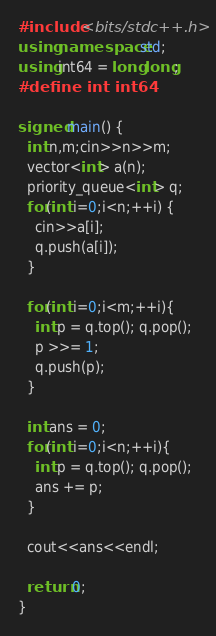Convert code to text. <code><loc_0><loc_0><loc_500><loc_500><_C++_>#include <bits/stdc++.h>
using namespace std;
using int64 = long long;
#define int int64

signed main() {
  int n,m;cin>>n>>m;
  vector<int> a(n);
  priority_queue<int> q;
  for(int i=0;i<n;++i) {
    cin>>a[i];
    q.push(a[i]);
  }

  for(int i=0;i<m;++i){
    int p = q.top(); q.pop();
    p >>= 1;
    q.push(p);
  }

  int ans = 0;
  for(int i=0;i<n;++i){
    int p = q.top(); q.pop();
    ans += p;
  }

  cout<<ans<<endl;
  
  return 0;
}
</code> 